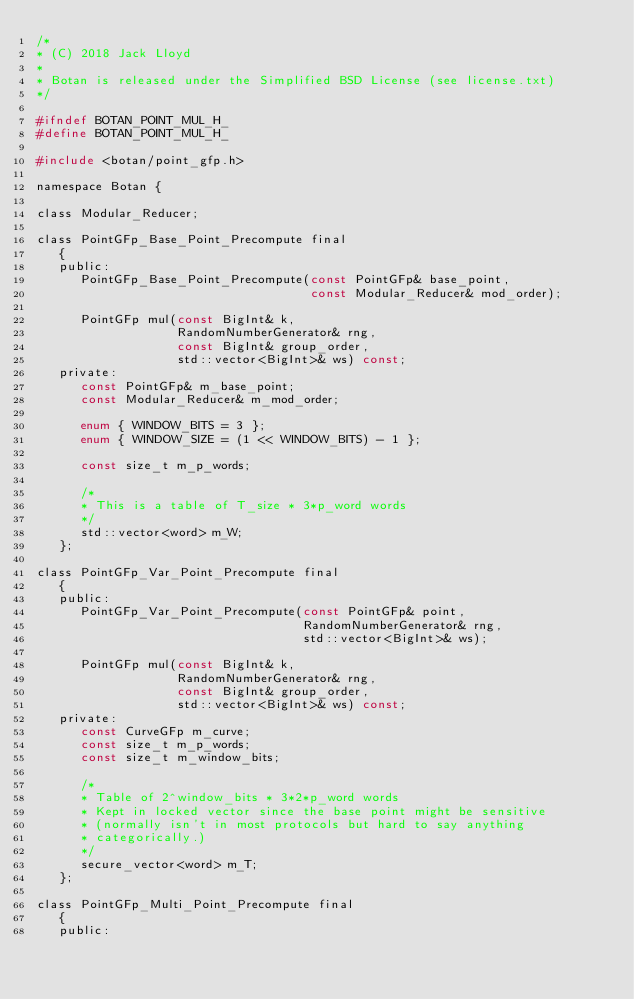Convert code to text. <code><loc_0><loc_0><loc_500><loc_500><_C_>/*
* (C) 2018 Jack Lloyd
*
* Botan is released under the Simplified BSD License (see license.txt)
*/

#ifndef BOTAN_POINT_MUL_H_
#define BOTAN_POINT_MUL_H_

#include <botan/point_gfp.h>

namespace Botan {

class Modular_Reducer;

class PointGFp_Base_Point_Precompute final
   {
   public:
      PointGFp_Base_Point_Precompute(const PointGFp& base_point,
                                     const Modular_Reducer& mod_order);

      PointGFp mul(const BigInt& k,
                   RandomNumberGenerator& rng,
                   const BigInt& group_order,
                   std::vector<BigInt>& ws) const;
   private:
      const PointGFp& m_base_point;
      const Modular_Reducer& m_mod_order;

      enum { WINDOW_BITS = 3 };
      enum { WINDOW_SIZE = (1 << WINDOW_BITS) - 1 };

      const size_t m_p_words;

      /*
      * This is a table of T_size * 3*p_word words
      */
      std::vector<word> m_W;
   };

class PointGFp_Var_Point_Precompute final
   {
   public:
      PointGFp_Var_Point_Precompute(const PointGFp& point,
                                    RandomNumberGenerator& rng,
                                    std::vector<BigInt>& ws);

      PointGFp mul(const BigInt& k,
                   RandomNumberGenerator& rng,
                   const BigInt& group_order,
                   std::vector<BigInt>& ws) const;
   private:
      const CurveGFp m_curve;
      const size_t m_p_words;
      const size_t m_window_bits;

      /*
      * Table of 2^window_bits * 3*2*p_word words
      * Kept in locked vector since the base point might be sensitive
      * (normally isn't in most protocols but hard to say anything
      * categorically.)
      */
      secure_vector<word> m_T;
   };

class PointGFp_Multi_Point_Precompute final
   {
   public:</code> 